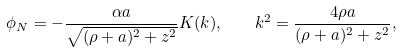Convert formula to latex. <formula><loc_0><loc_0><loc_500><loc_500>\phi _ { N } = - \frac { \alpha a } { \sqrt { ( \rho + a ) ^ { 2 } + z ^ { 2 } } } K ( k ) , \quad k ^ { 2 } = \frac { 4 \rho a } { ( \rho + a ) ^ { 2 } + z ^ { 2 } } ,</formula> 